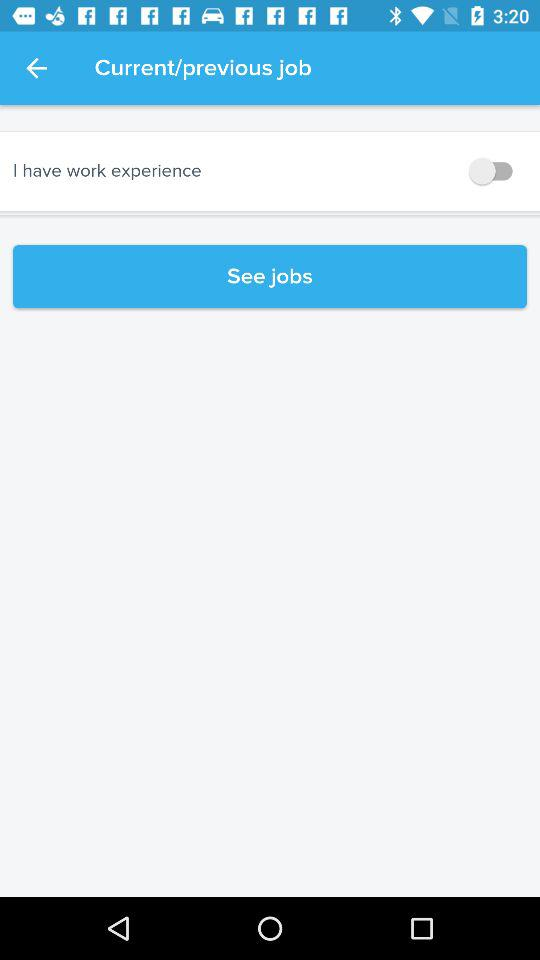What is the setting for current/previous job?
When the provided information is insufficient, respond with <no answer>. <no answer> 